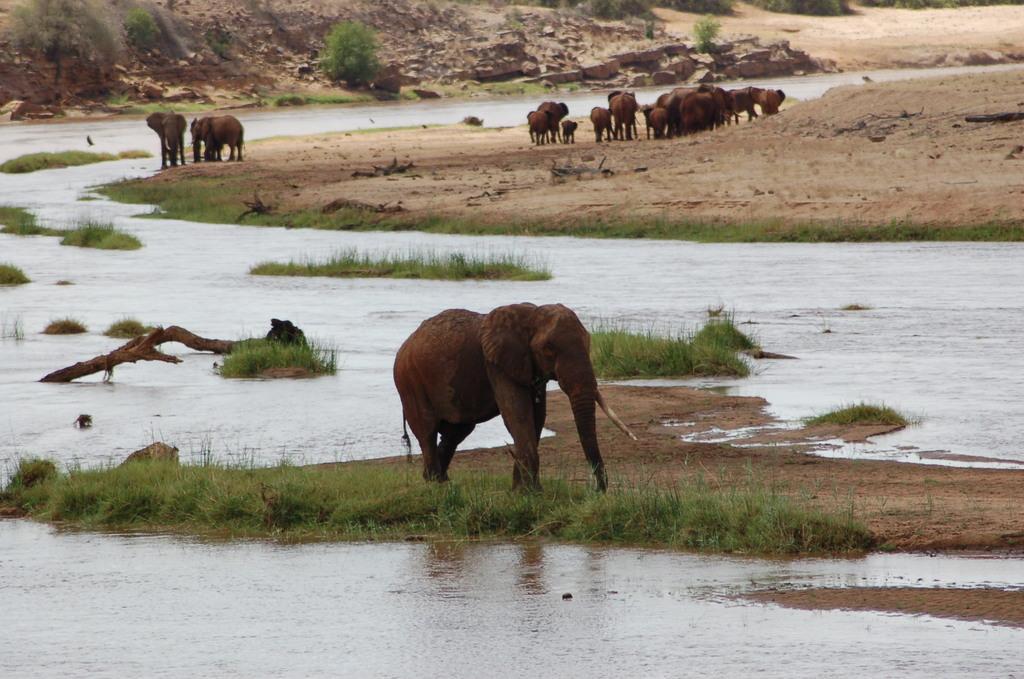In one or two sentences, can you explain what this image depicts? Here we can see an elephant walking on grass and we can see water. Background we can see elephants,animals and plants. 